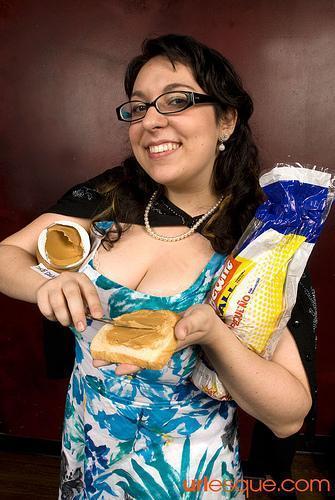How many slices of pizza does this person have?
Give a very brief answer. 0. 